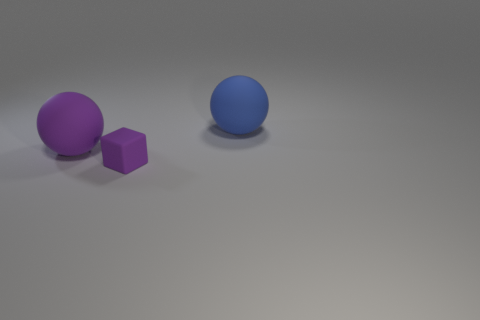Add 3 purple things. How many objects exist? 6 Subtract all purple spheres. How many spheres are left? 1 Subtract 1 cubes. How many cubes are left? 0 Add 3 tiny brown matte things. How many tiny brown matte things exist? 3 Subtract 0 brown cylinders. How many objects are left? 3 Subtract all cubes. How many objects are left? 2 Subtract all green cubes. Subtract all purple cylinders. How many cubes are left? 1 Subtract all cyan spheres. How many yellow cubes are left? 0 Subtract all cyan blocks. Subtract all purple spheres. How many objects are left? 2 Add 3 purple balls. How many purple balls are left? 4 